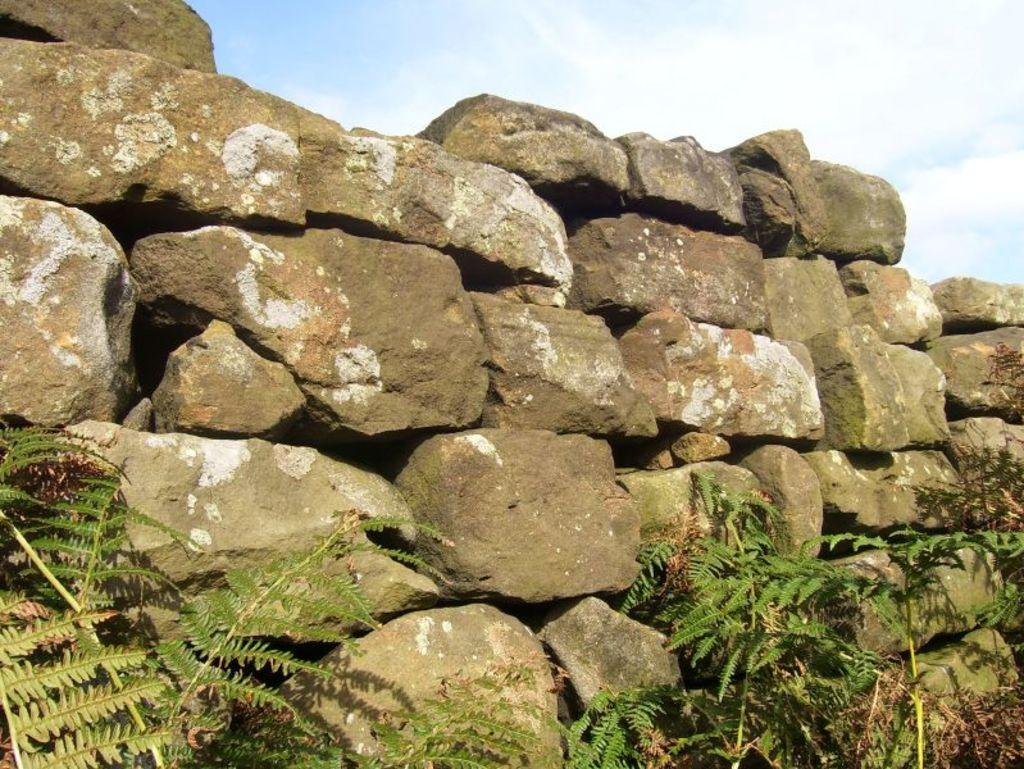What type of vegetation is at the bottom of the image? There are plants at the bottom of the image. What other objects can be seen in the middle of the image? There are stones in the middle of the image. What is visible at the top of the image? The sky is visible at the top of the image. How would you describe the sky in the image? The sky appears to be cloudy. Can you see the family sitting on the lamp in the image? There is no family or lamp present in the image. How many bees are buzzing around the plants in the image? There are no bees visible in the image; it only features plants, stones, and a cloudy sky. 